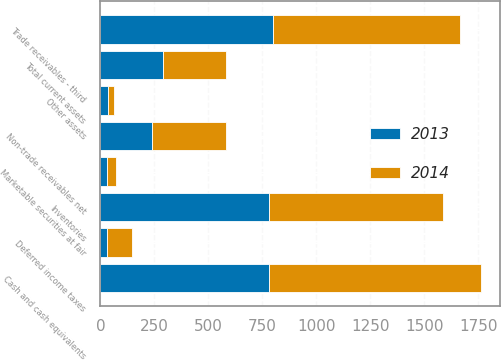<chart> <loc_0><loc_0><loc_500><loc_500><stacked_bar_chart><ecel><fcel>Cash and cash equivalents<fcel>Trade receivables - third<fcel>Non-trade receivables net<fcel>Inventories<fcel>Deferred income taxes<fcel>Marketable securities at fair<fcel>Other assets<fcel>Total current assets<nl><fcel>2013<fcel>780<fcel>801<fcel>241<fcel>782<fcel>29<fcel>32<fcel>33<fcel>292<nl><fcel>2014<fcel>984<fcel>867<fcel>343<fcel>804<fcel>115<fcel>41<fcel>28<fcel>292<nl></chart> 